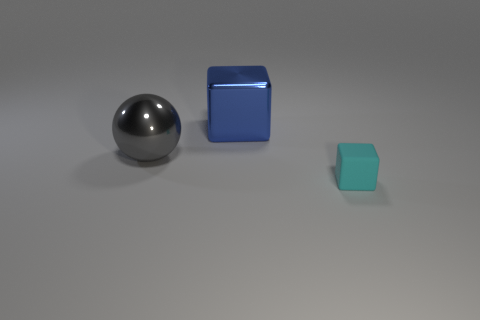Is there any other thing that is the same size as the rubber thing?
Your answer should be very brief. No. There is a block that is in front of the large blue metal cube; is it the same color as the block that is left of the small object?
Offer a very short reply. No. Is the number of tiny cyan rubber things that are right of the shiny sphere greater than the number of cyan blocks to the left of the rubber block?
Make the answer very short. Yes. What color is the tiny matte thing that is the same shape as the big blue metal thing?
Your answer should be compact. Cyan. Are there any other things that have the same shape as the tiny cyan object?
Give a very brief answer. Yes. Is the shape of the blue object the same as the shiny thing that is in front of the blue shiny object?
Your answer should be very brief. No. What number of other objects are the same material as the big cube?
Give a very brief answer. 1. There is a tiny object; is it the same color as the cube that is left of the cyan cube?
Offer a terse response. No. There is a thing on the left side of the metallic block; what is its material?
Your answer should be compact. Metal. Are there any small rubber objects of the same color as the metallic sphere?
Make the answer very short. No. 